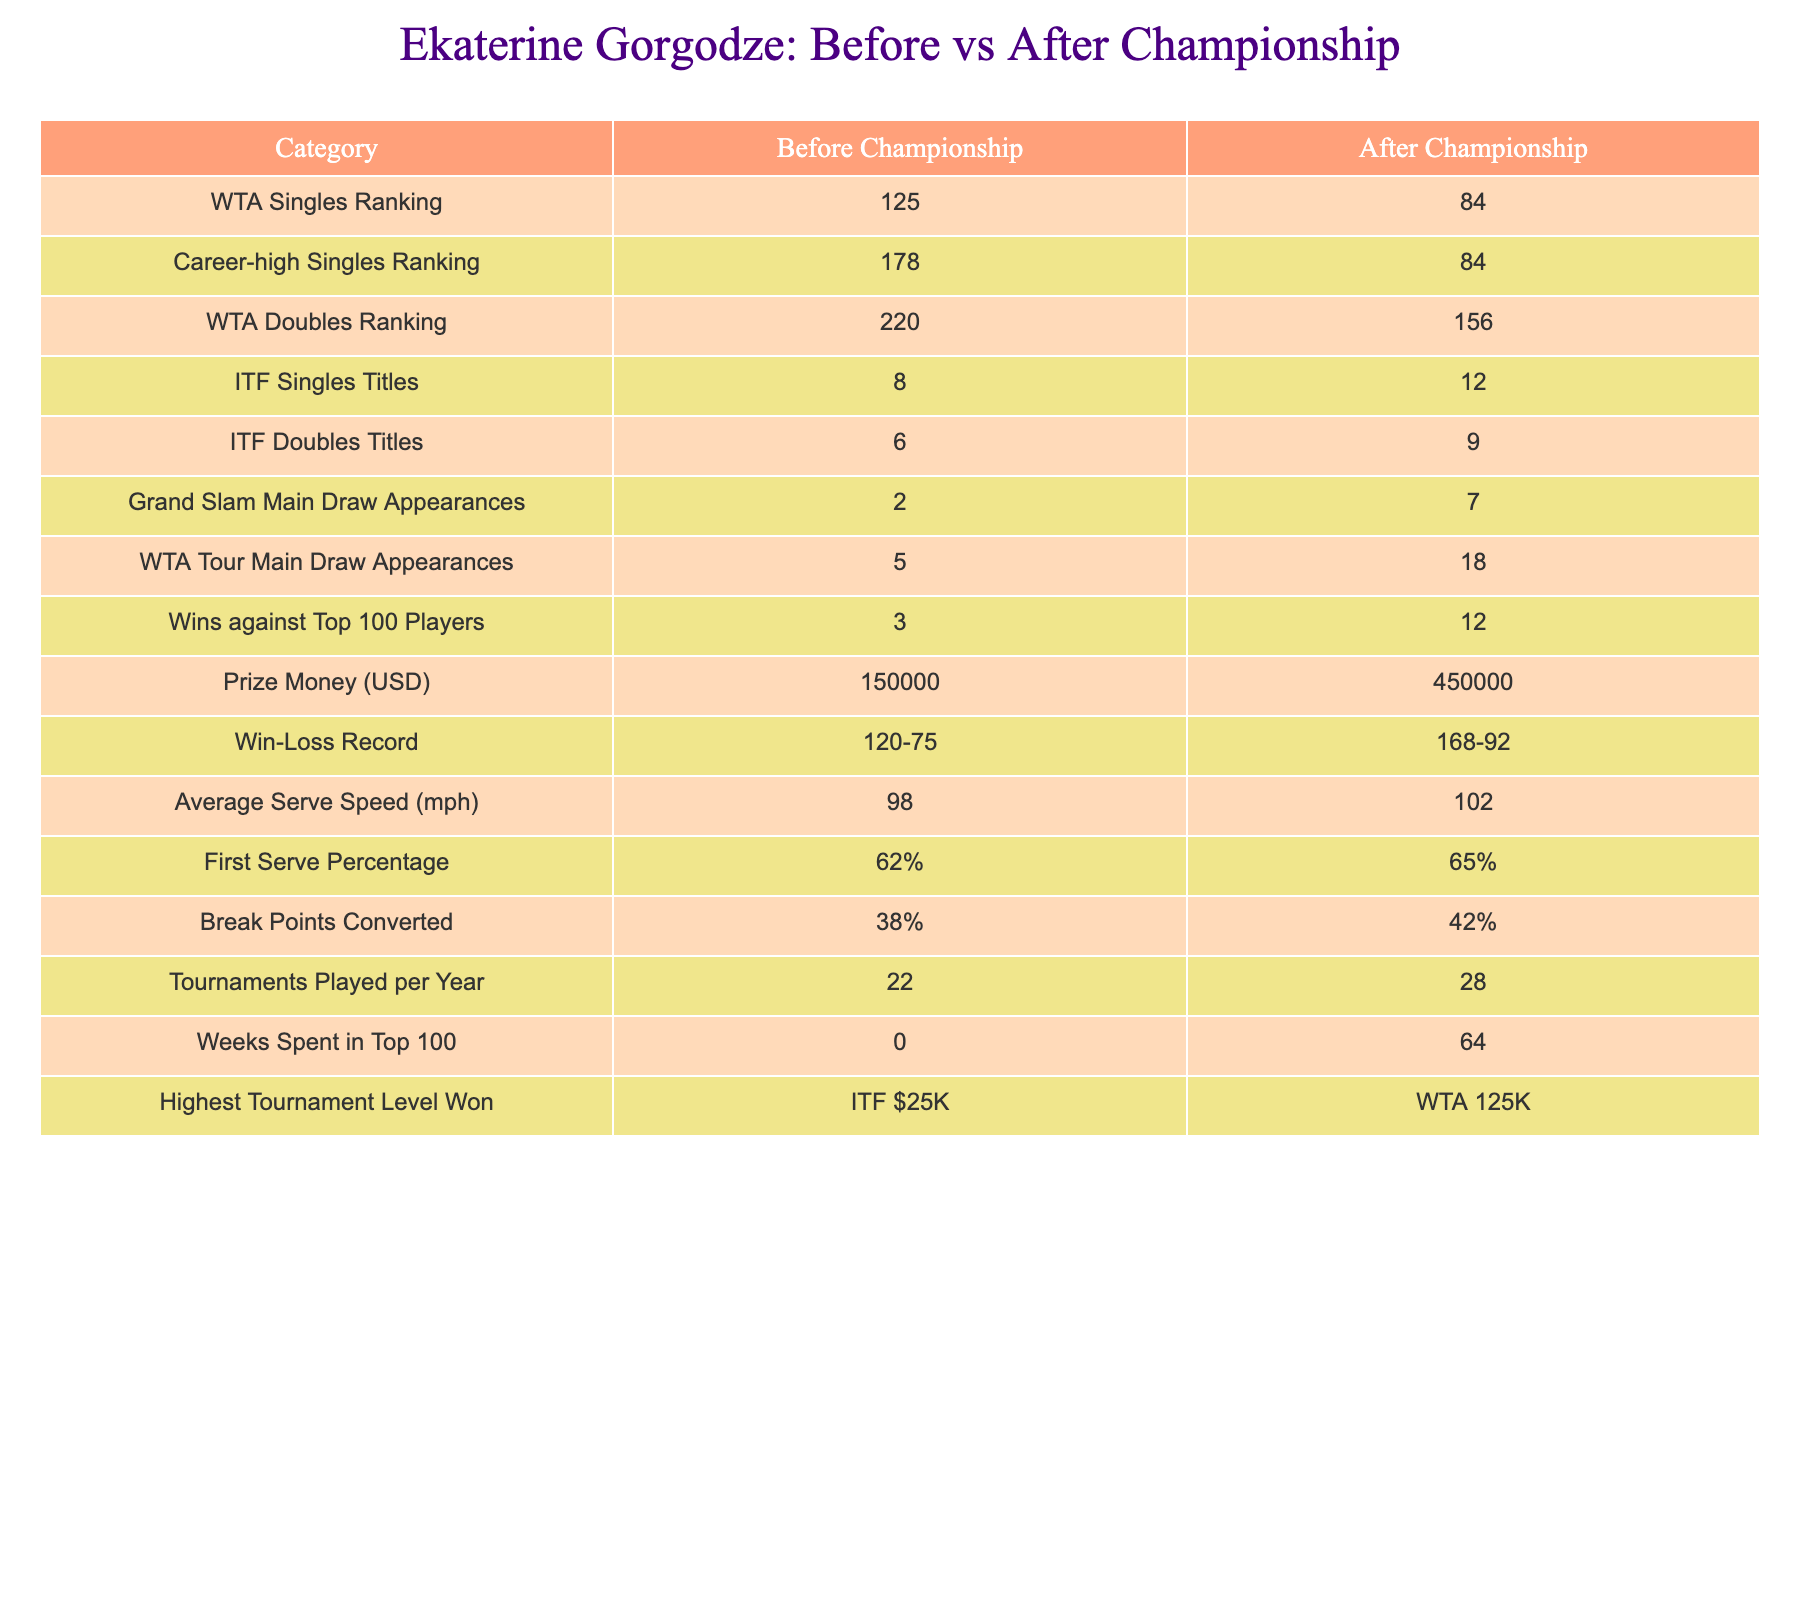What was Ekaterine Gorgodze's WTA Singles Ranking before the championship? The table directly provides the WTA Singles Ranking before the championship, which is listed as 125.
Answer: 125 How many WTA Tour Main Draw Appearances did Gorgodze have after her championship win? The table states that after the championship, Gorgodze had 18 WTA Tour Main Draw Appearances.
Answer: 18 What is the difference in Prize Money (USD) earned before and after the championship? To find the difference, subtract the Prize Money before the championship (150000) from the Prize Money after (450000). Therefore, 450000 - 150000 = 300000.
Answer: 300000 Did Gorgodze win more ITF Singles Titles before or after her championship? Before the championship, she had 8 ITF Singles Titles, while after she had 12. Since 12 is greater than 8, the answer is yes, she won more after.
Answer: Yes What was Ekaterine Gorgodze's highest tournament level won before her championship? The table indicates that before her championship win, Gorgodze's highest tournament level was ITF $25K.
Answer: ITF $25K How many weeks did Gorgodze spend in the top 100 before her championship? According to the table, Gorgodze spent 0 weeks in the top 100 before her championship.
Answer: 0 What is the average increase in Break Points Converted before and after the championship? Before the championship, her Break Points Converted percentage was 38%, and after it increased to 42%. To find the average increase: (42 - 38) / 2 = 2.
Answer: 2 Which category shows the most improvement in terms of WTA Singles Ranking? Gorgodze's WTA Singles Ranking improved from 125 before the championship to 84 after. The improvement is significant, indicating a move upwards in rank.
Answer: WTA Singles Ranking How many more Grand Slam Main Draw Appearances did Gorgodze have post-championship compared to pre-championship? Before the championship, she had 2 Grand Slam Main Draw Appearances and after she had 7. The difference is 7 - 2 = 5, indicating more appearances.
Answer: 5 